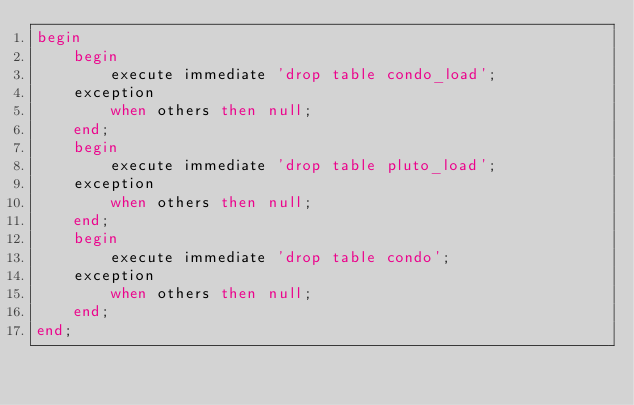Convert code to text. <code><loc_0><loc_0><loc_500><loc_500><_SQL_>begin
    begin
        execute immediate 'drop table condo_load';
    exception
        when others then null;
    end;
    begin
        execute immediate 'drop table pluto_load';
    exception
        when others then null;
    end;
    begin
        execute immediate 'drop table condo';
    exception
        when others then null;
    end;
end;</code> 